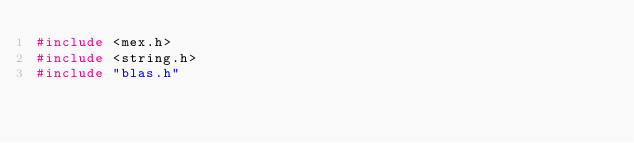Convert code to text. <code><loc_0><loc_0><loc_500><loc_500><_C++_>#include <mex.h>
#include <string.h> 
#include "blas.h"</code> 